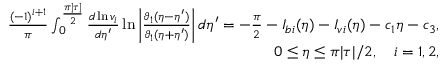<formula> <loc_0><loc_0><loc_500><loc_500>\begin{array} { r } { \frac { ( - 1 ) ^ { i + 1 } } { \pi } \int _ { 0 } ^ { \frac { \pi | \tau | } { 2 } } \frac { d \ln v _ { i } } { d \eta ^ { \prime } } \ln \left | \frac { \vartheta _ { 1 } ( \eta - \eta ^ { \prime } ) } { \vartheta _ { 1 } ( \eta + \eta ^ { \prime } ) } \right | d \eta ^ { \prime } = - \frac { \pi } { 2 } - I _ { b i } ( \eta ) - I _ { v i } ( \eta ) - c _ { 1 } \eta - c _ { 3 } , } \\ { 0 \leq \eta \leq \pi | \tau | / 2 , \quad i = 1 , 2 , } \end{array}</formula> 